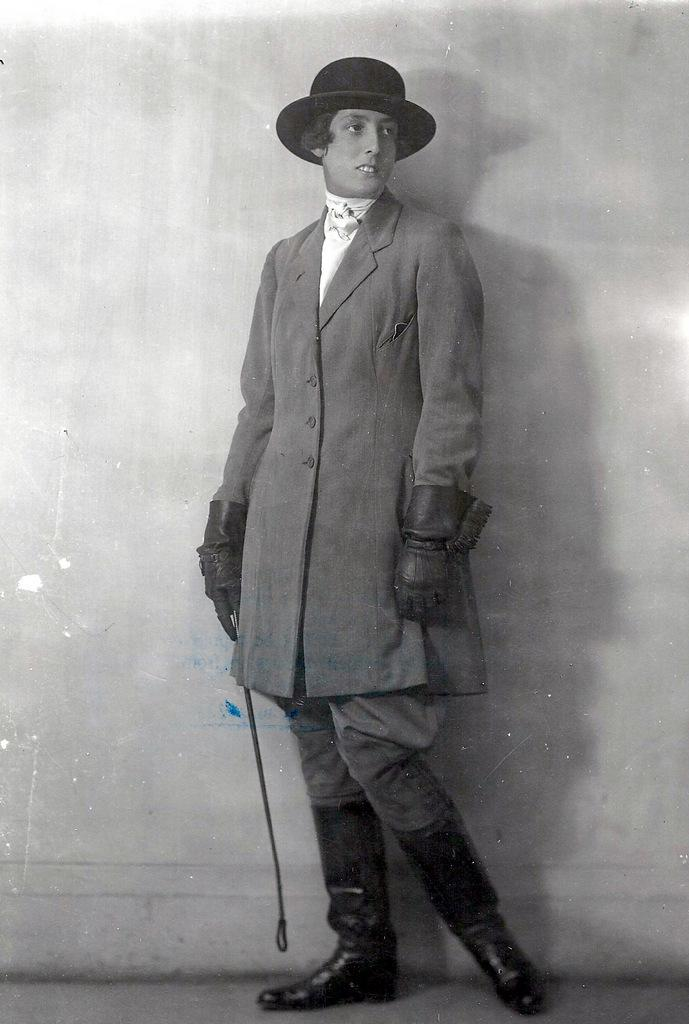What type of image is being described? The image is a photograph. Can you describe the person in the image? There is a person standing in the image. What is the person holding in their hand? The person is holding something in their hand. How does the person in the image maintain their balance while holding the object? The image does not provide information about the person's balance or the object's weight, so it cannot be determined from the image. 